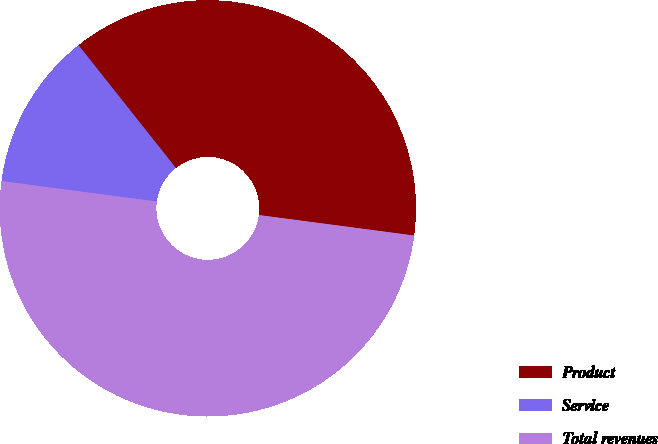<chart> <loc_0><loc_0><loc_500><loc_500><pie_chart><fcel>Product<fcel>Service<fcel>Total revenues<nl><fcel>37.76%<fcel>12.24%<fcel>50.0%<nl></chart> 